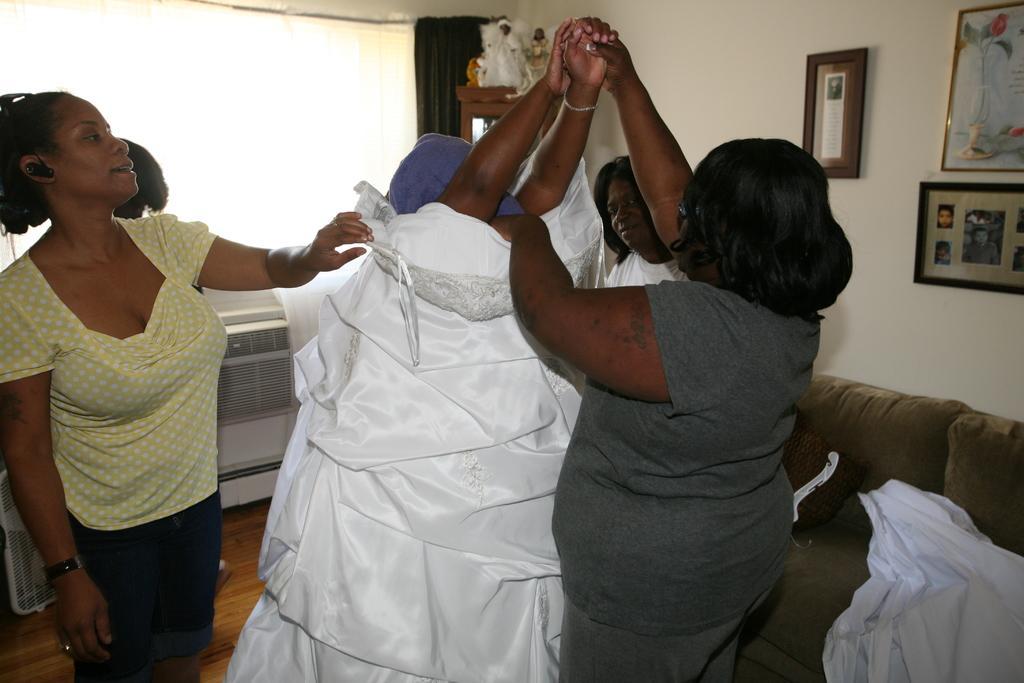Describe this image in one or two sentences. In this picture we can observe some women standing. There is a white color dress. On the right side there is a sofa. There are some photo frames fixed to the wall. In the background there is a black color curtain and a window. 